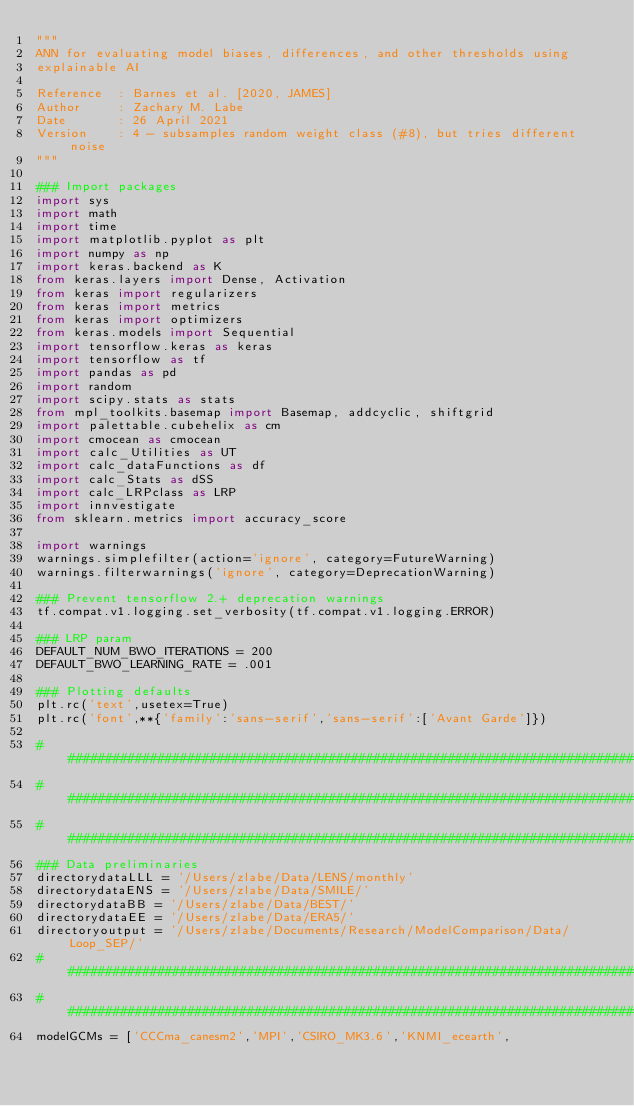<code> <loc_0><loc_0><loc_500><loc_500><_Python_>"""
ANN for evaluating model biases, differences, and other thresholds using 
explainable AI

Reference  : Barnes et al. [2020, JAMES]
Author     : Zachary M. Labe
Date       : 26 April 2021
Version    : 4 - subsamples random weight class (#8), but tries different noise
"""

### Import packages
import sys
import math
import time
import matplotlib.pyplot as plt
import numpy as np
import keras.backend as K
from keras.layers import Dense, Activation
from keras import regularizers
from keras import metrics
from keras import optimizers
from keras.models import Sequential
import tensorflow.keras as keras
import tensorflow as tf
import pandas as pd
import random
import scipy.stats as stats
from mpl_toolkits.basemap import Basemap, addcyclic, shiftgrid
import palettable.cubehelix as cm
import cmocean as cmocean
import calc_Utilities as UT
import calc_dataFunctions as df
import calc_Stats as dSS
import calc_LRPclass as LRP
import innvestigate
from sklearn.metrics import accuracy_score

import warnings
warnings.simplefilter(action='ignore', category=FutureWarning)
warnings.filterwarnings('ignore', category=DeprecationWarning)

### Prevent tensorflow 2.+ deprecation warnings
tf.compat.v1.logging.set_verbosity(tf.compat.v1.logging.ERROR)

### LRP param
DEFAULT_NUM_BWO_ITERATIONS = 200
DEFAULT_BWO_LEARNING_RATE = .001

### Plotting defaults 
plt.rc('text',usetex=True)
plt.rc('font',**{'family':'sans-serif','sans-serif':['Avant Garde']}) 

###############################################################################
###############################################################################
###############################################################################
### Data preliminaries 
directorydataLLL = '/Users/zlabe/Data/LENS/monthly'
directorydataENS = '/Users/zlabe/Data/SMILE/'
directorydataBB = '/Users/zlabe/Data/BEST/'
directorydataEE = '/Users/zlabe/Data/ERA5/'
directoryoutput = '/Users/zlabe/Documents/Research/ModelComparison/Data/Loop_SEP/'
###############################################################################
###############################################################################
modelGCMs = ['CCCma_canesm2','MPI','CSIRO_MK3.6','KNMI_ecearth',</code> 